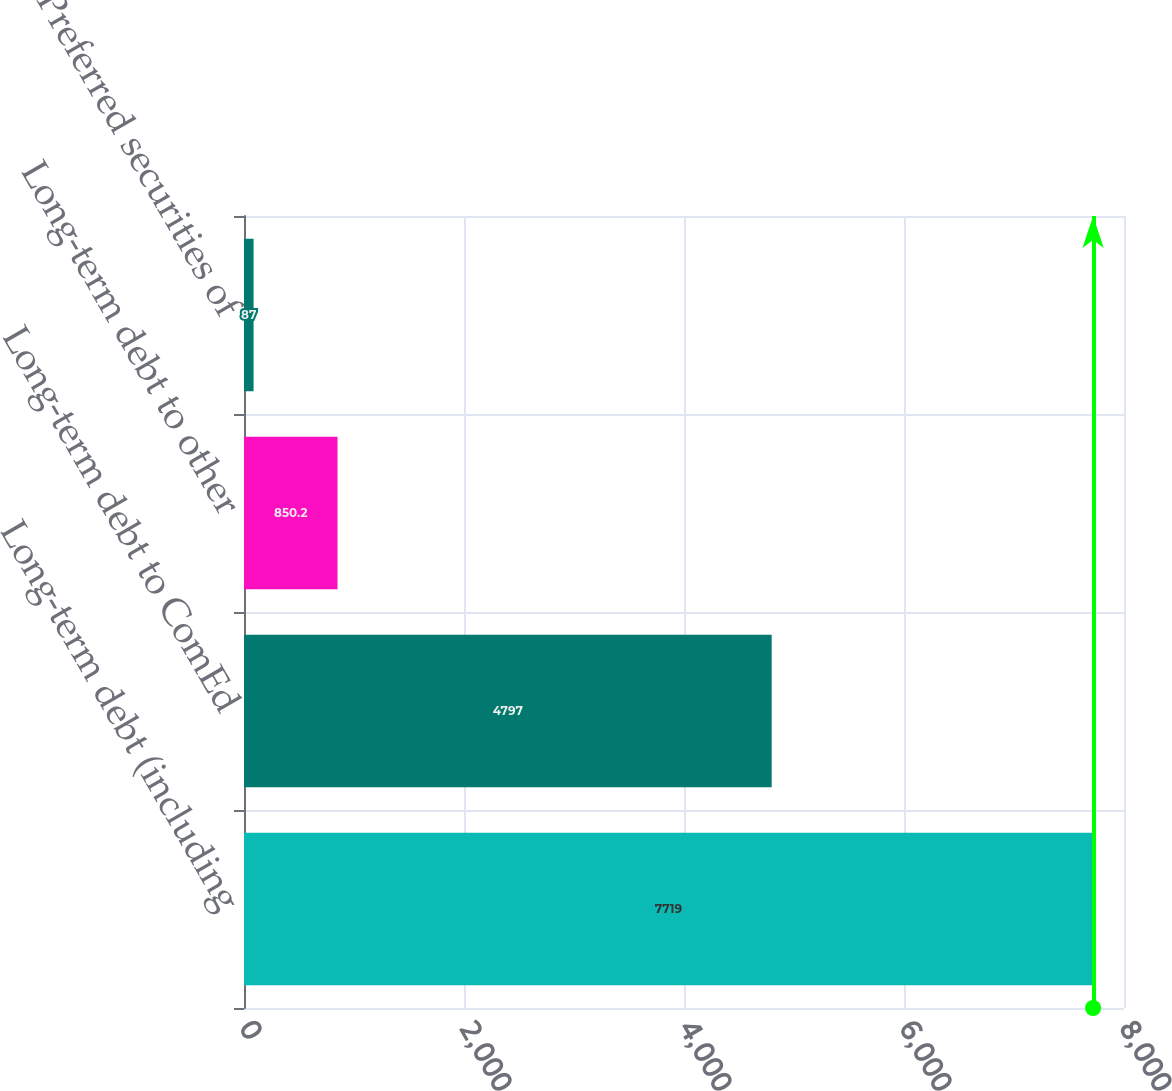Convert chart. <chart><loc_0><loc_0><loc_500><loc_500><bar_chart><fcel>Long-term debt (including<fcel>Long-term debt to ComEd<fcel>Long-term debt to other<fcel>Preferred securities of<nl><fcel>7719<fcel>4797<fcel>850.2<fcel>87<nl></chart> 